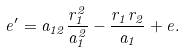<formula> <loc_0><loc_0><loc_500><loc_500>e ^ { \prime } = a _ { 1 2 } \frac { r _ { 1 } ^ { 2 } } { a _ { 1 } ^ { 2 } } - \frac { r _ { 1 } r _ { 2 } } { a _ { 1 } } + e .</formula> 